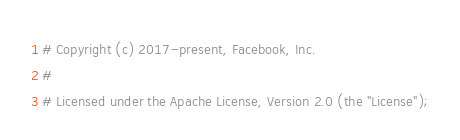Convert code to text. <code><loc_0><loc_0><loc_500><loc_500><_Python_># Copyright (c) 2017-present, Facebook, Inc.
#
# Licensed under the Apache License, Version 2.0 (the "License");</code> 